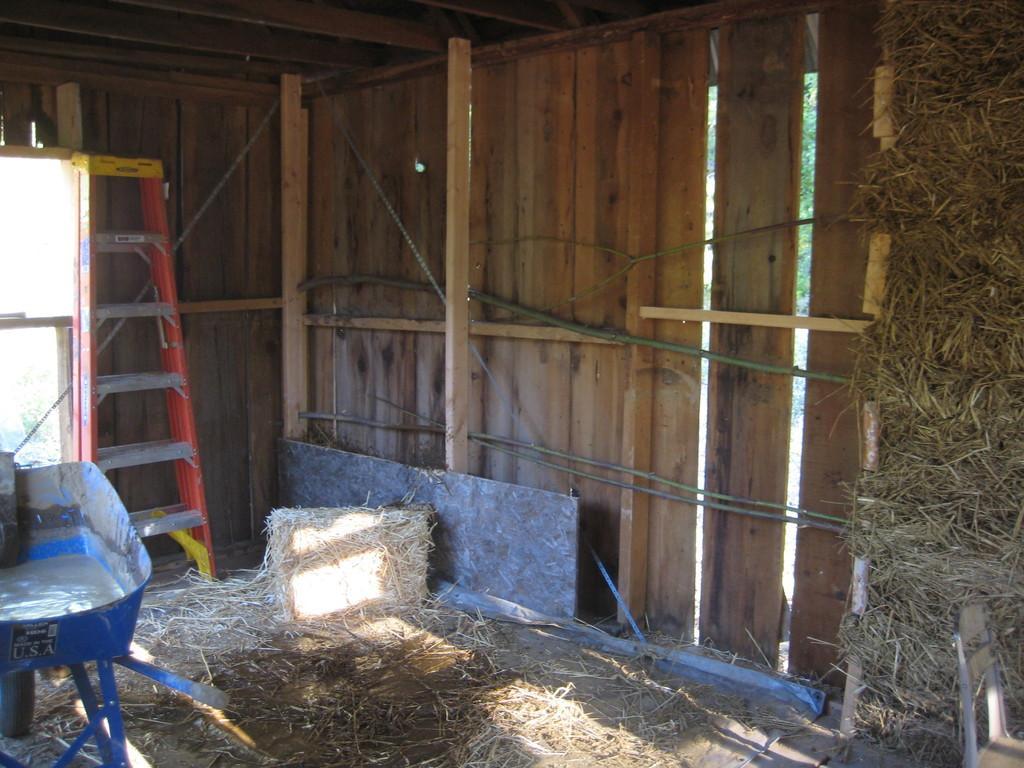How would you summarize this image in a sentence or two? This picture might be taken inside of a shelter, in this image there is a wooden wall, wooden poles, ladder, grass and some other objects. 